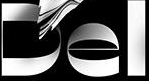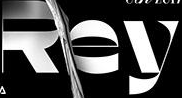Read the text from these images in sequence, separated by a semicolon. Del; Rey 